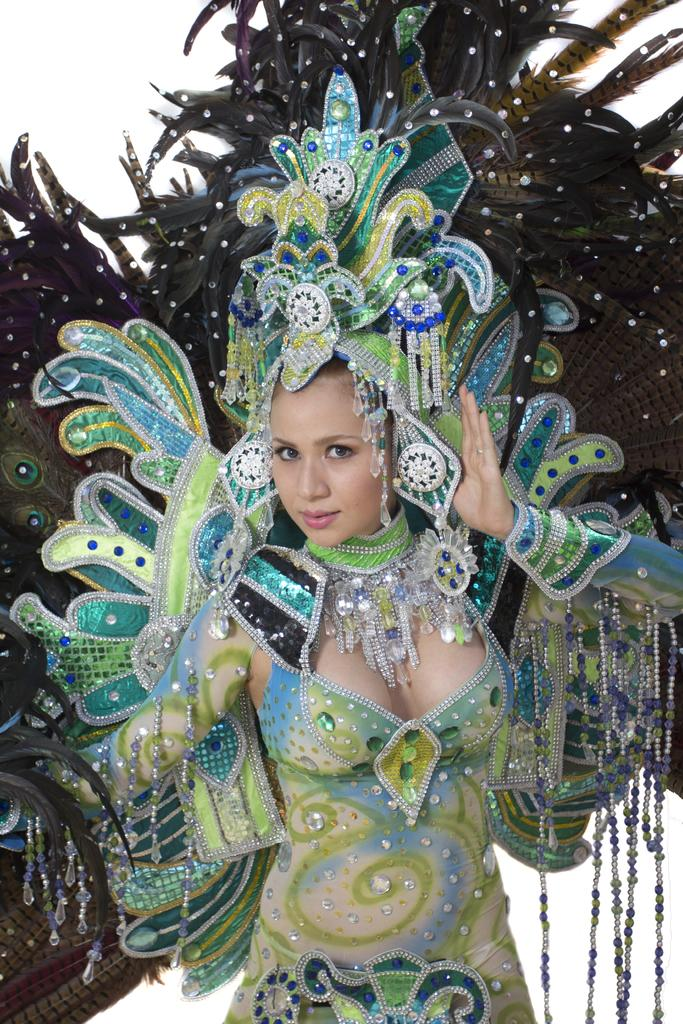What is the main subject of the image? There is a woman standing in the image. Can you describe the woman's attire? The woman is wearing a fancy dress that appears to have feathers. What is the color of the background in the image? The background of the image is white in color. What type of reward is the woman holding in the image? There is no reward visible in the image; the woman is simply standing in her fancy dress. 